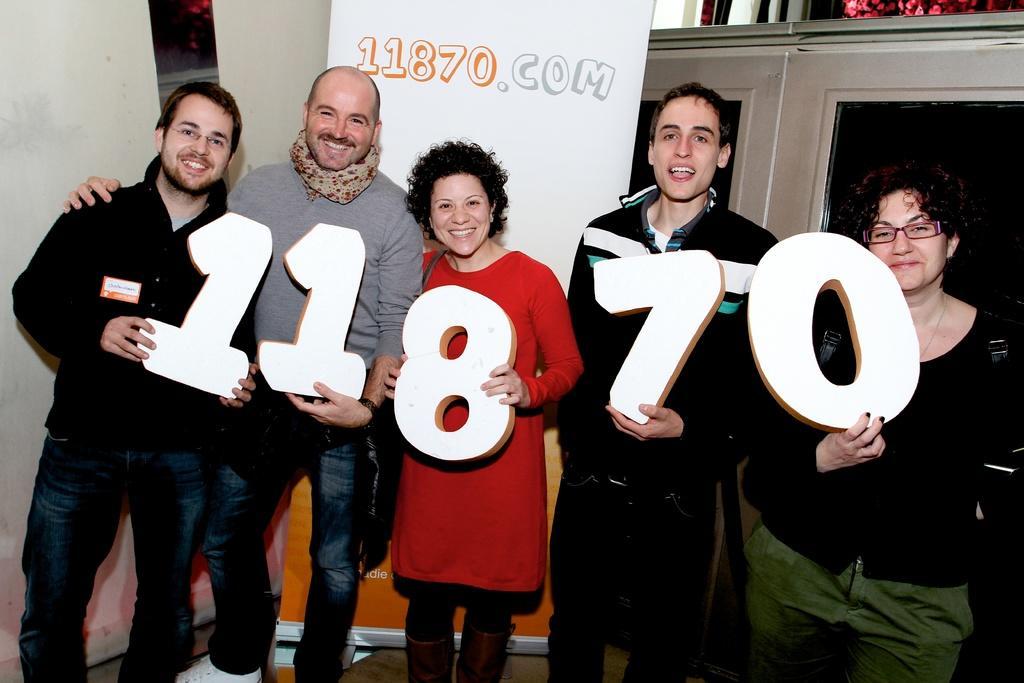Can you describe this image briefly? In this image in the center there are group of persons standing and holding numbers in their hands and smiling. In the background there is a board with some text and numbers written on it and there is a wall. On the right side there is a door. 